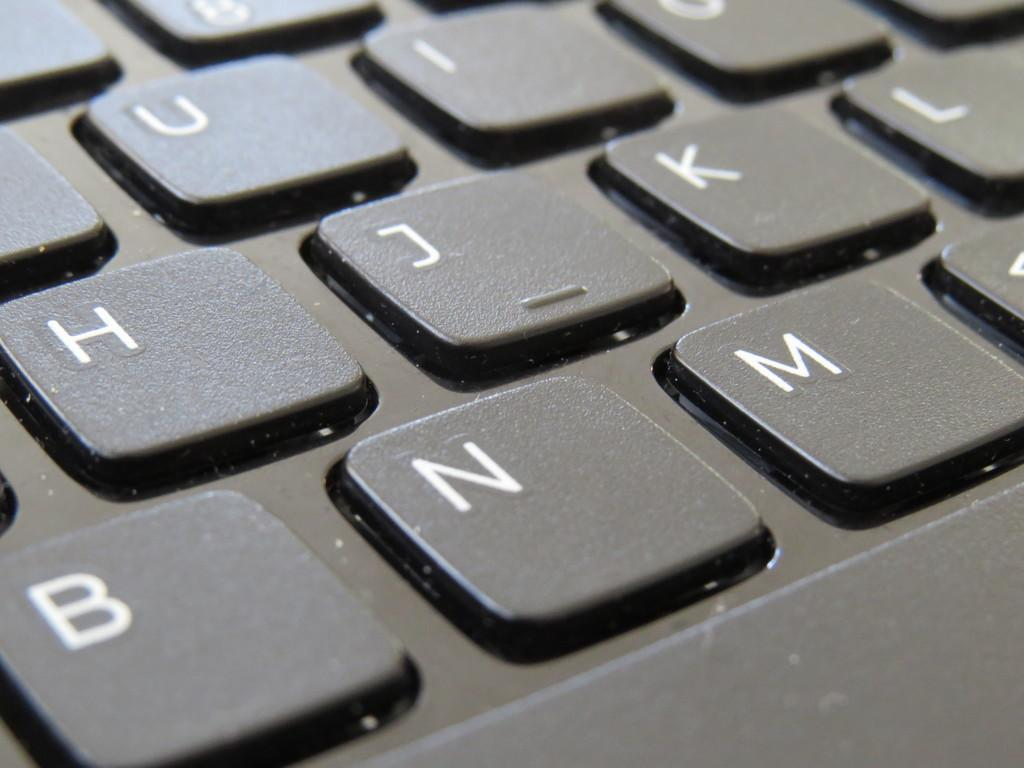<image>
Offer a succinct explanation of the picture presented. Black and white keyboard that contains letters on the buttons 